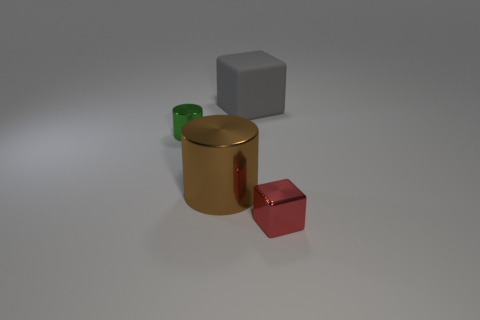How does the lighting in this image affect the mood or tone? The lighting in the image is soft and diffused, creating a calm and neutral atmosphere. It emphasizes the shininess of the surfaces and adds to the overall serene and clean aesthetic of the scene. 